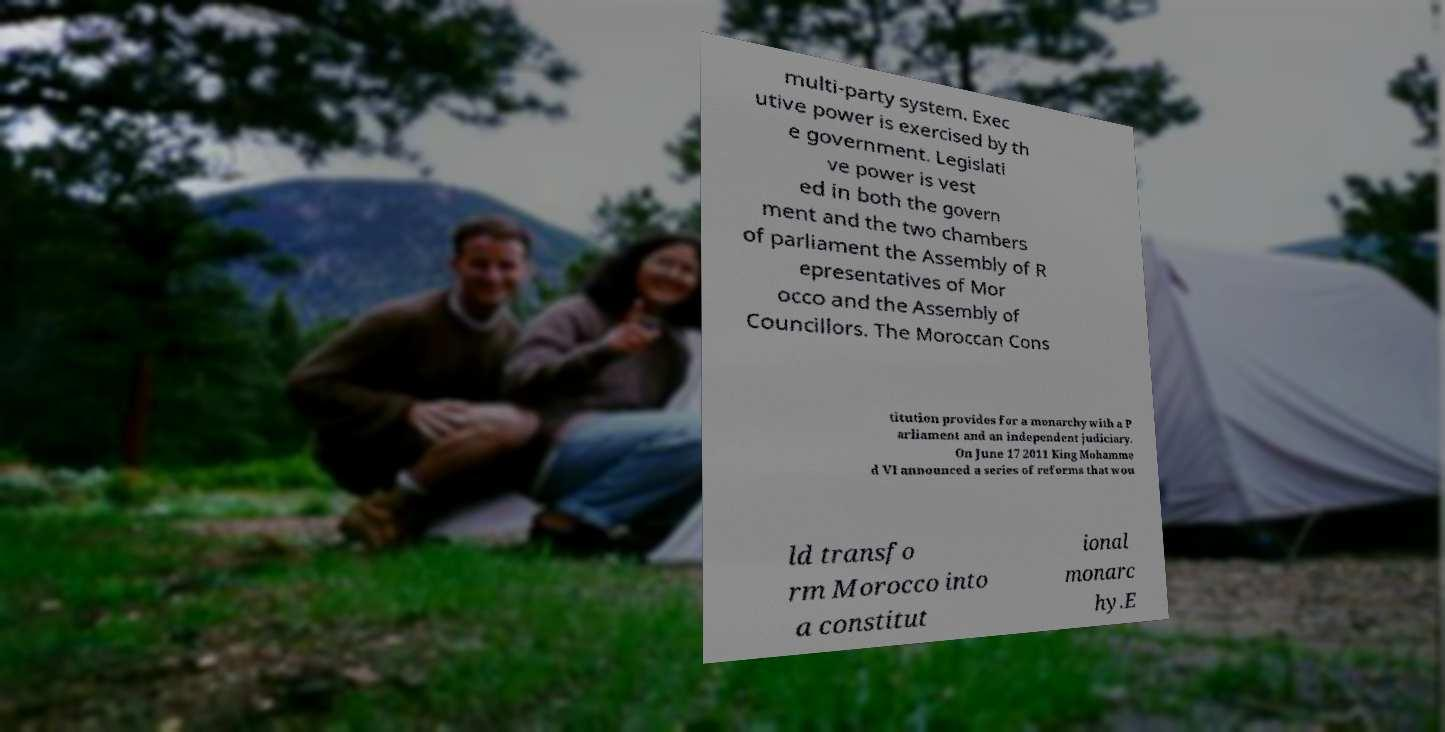Could you assist in decoding the text presented in this image and type it out clearly? multi-party system. Exec utive power is exercised by th e government. Legislati ve power is vest ed in both the govern ment and the two chambers of parliament the Assembly of R epresentatives of Mor occo and the Assembly of Councillors. The Moroccan Cons titution provides for a monarchy with a P arliament and an independent judiciary. On June 17 2011 King Mohamme d VI announced a series of reforms that wou ld transfo rm Morocco into a constitut ional monarc hy.E 